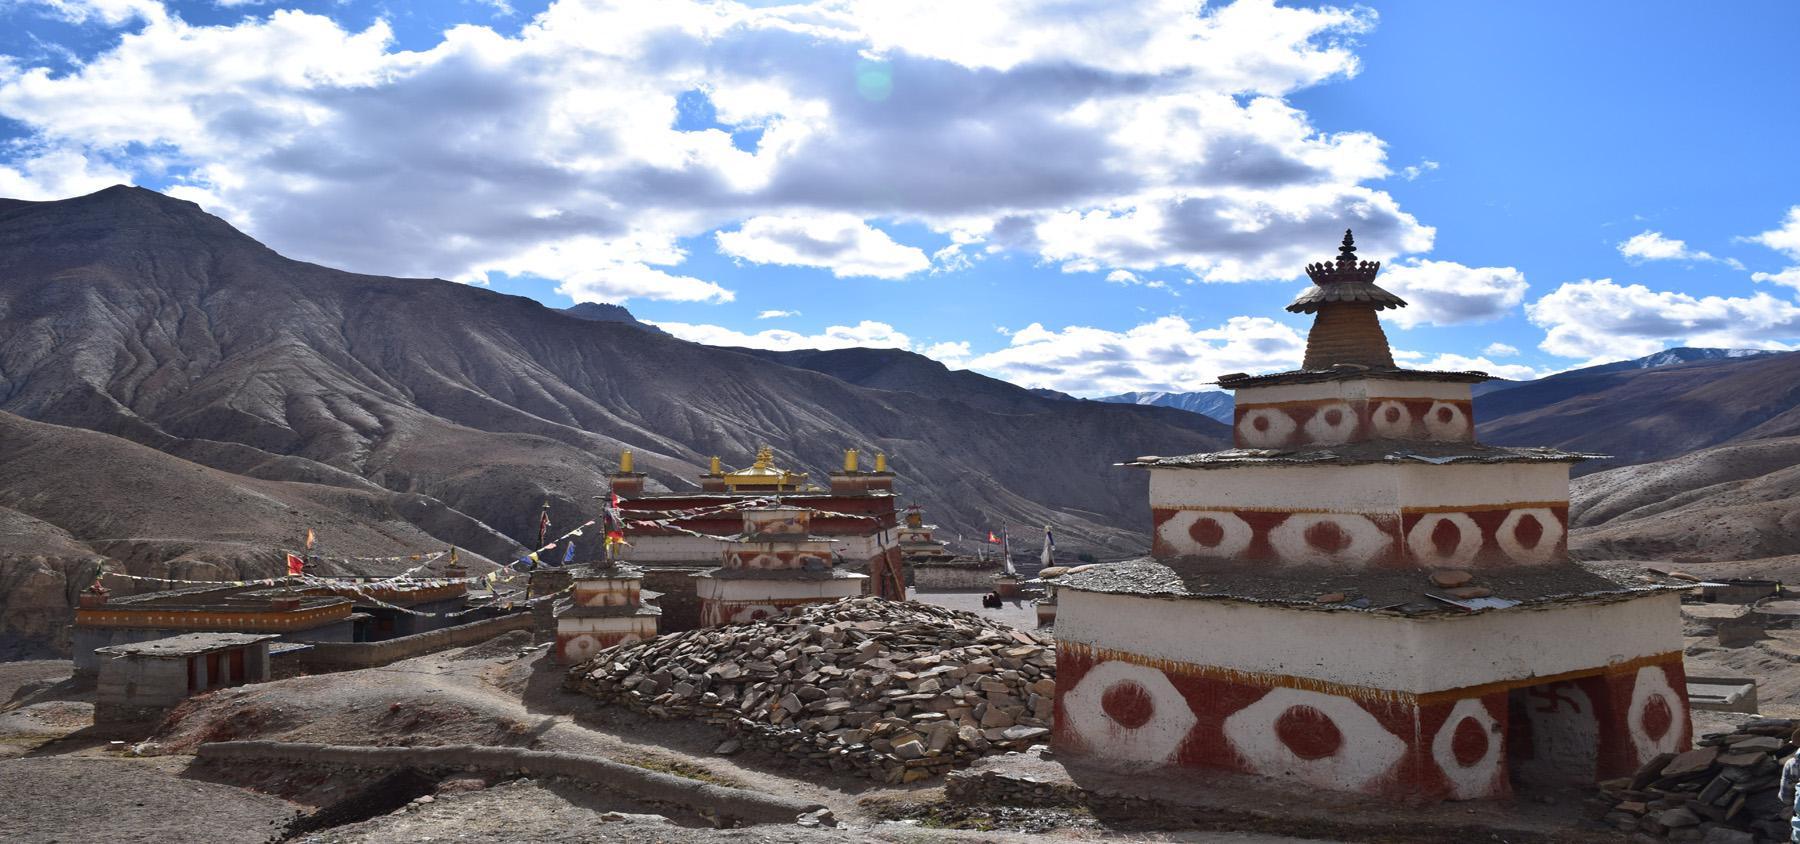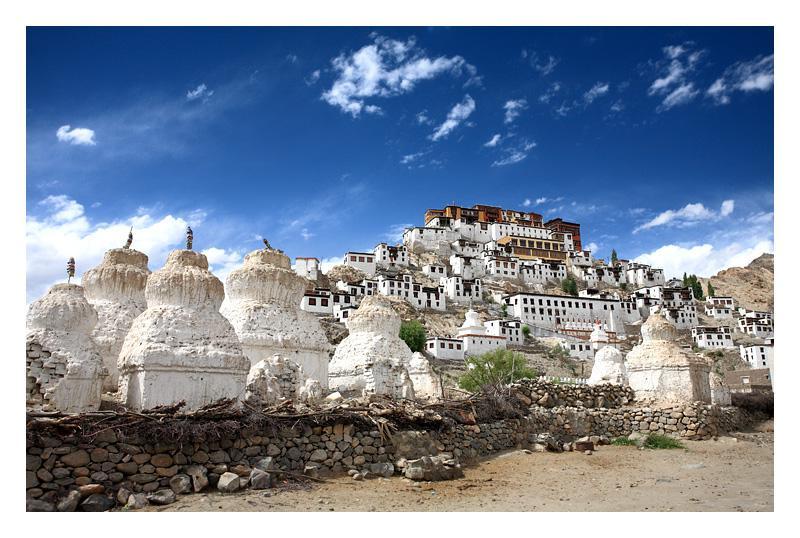The first image is the image on the left, the second image is the image on the right. Considering the images on both sides, is "An image shows a hillside covered with buildings with windows, and rustic white structures in the foreground." valid? Answer yes or no. Yes. 